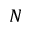<formula> <loc_0><loc_0><loc_500><loc_500>N</formula> 